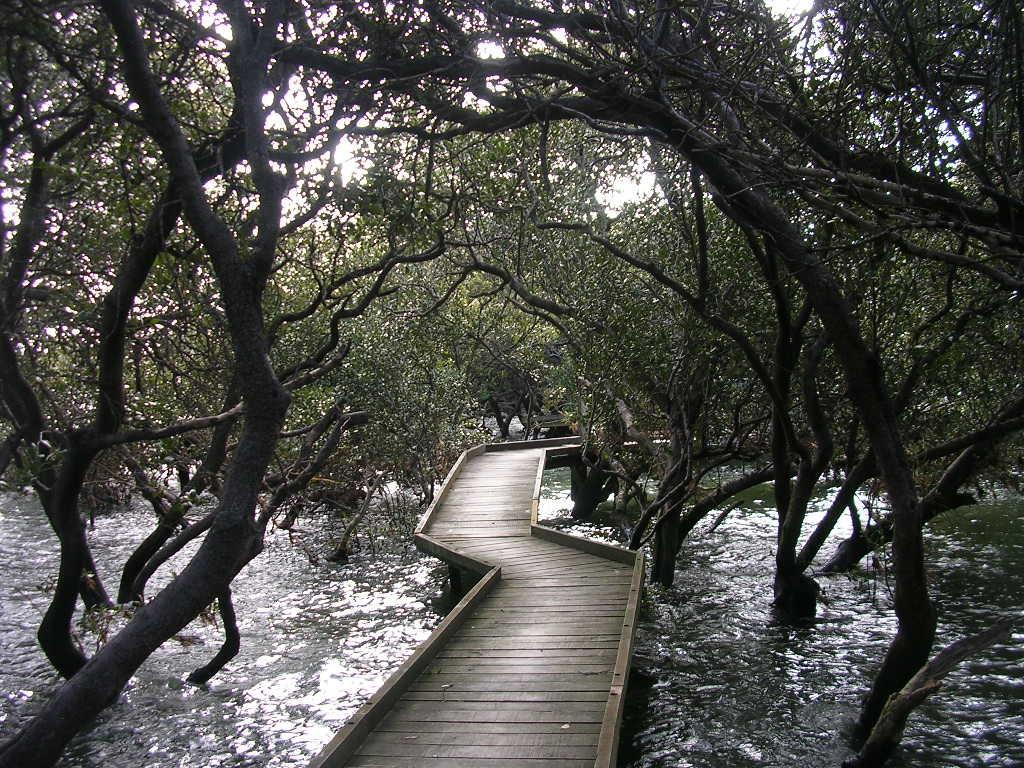What type of structure is located at the center of the image? There is a wooden pier in the image. Where is the wooden pier situated in relation to the other elements in the image? The wooden pier is at the center of the image. What can be seen in the background of the image? There is water visible in the image, and trees are present on either side of the water. What type of plate is floating on the water in the image? There is no plate present in the image; it only features a wooden pier, water, and trees. 